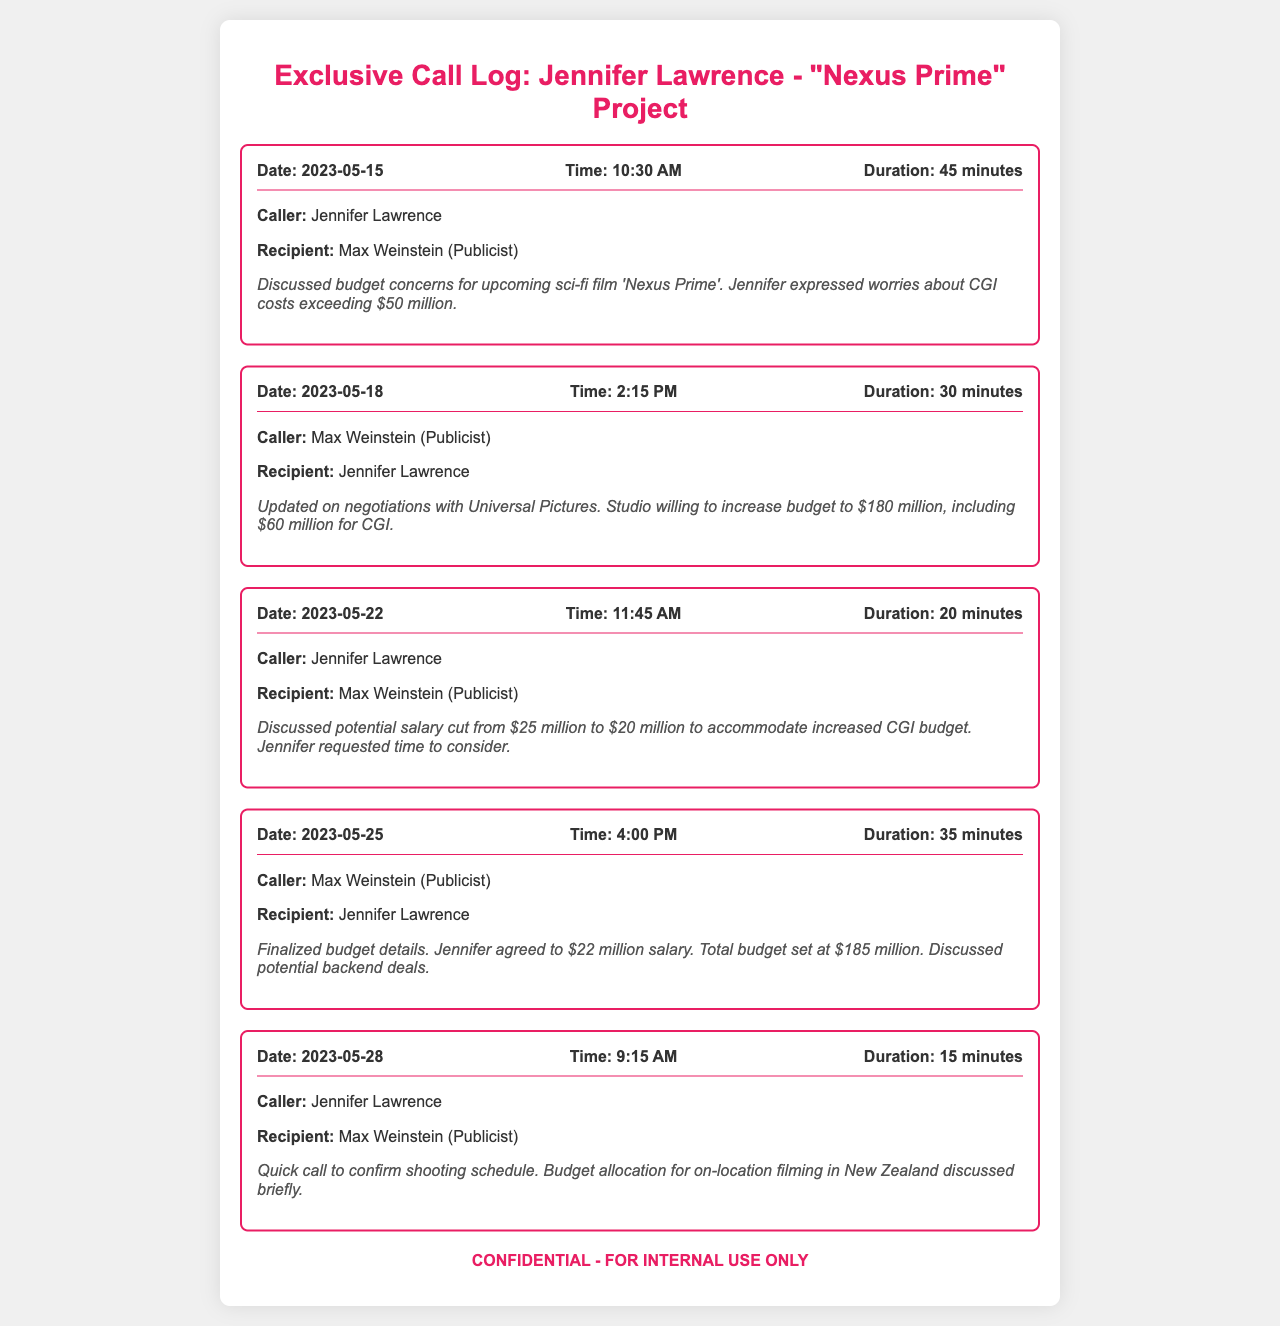What is the caller's name on May 15? Jennifer Lawrence is identified as the caller in the call log for May 15.
Answer: Jennifer Lawrence What was the duration of the call on May 18? The call on May 18 lasted for 30 minutes, as stated in the call log.
Answer: 30 minutes How much is Jennifer's salary after negotiation? Jennifer's agreed salary is noted as $22 million in the final call log entry.
Answer: $22 million On which date was the final budget discussed? The final budget details were finalized during the call on May 25.
Answer: May 25 What was the original CGI cost concern? Jennifer expressed concerns about CGI costs exceeding $50 million during her call.
Answer: $50 million What was the total budget set for 'Nexus Prime'? The total budget for the film is indicated as $185 million in the call log.
Answer: $185 million Who was the recipient of the call on May 22? The recipient of the call on May 22 was Max Weinstein.
Answer: Max Weinstein What film title is being discussed in the call log? The title of the film being discussed is 'Nexus Prime.'
Answer: Nexus Prime What did Jennifer request time to consider? Jennifer requested time to consider the potential salary cut during her call.
Answer: Salary cut 